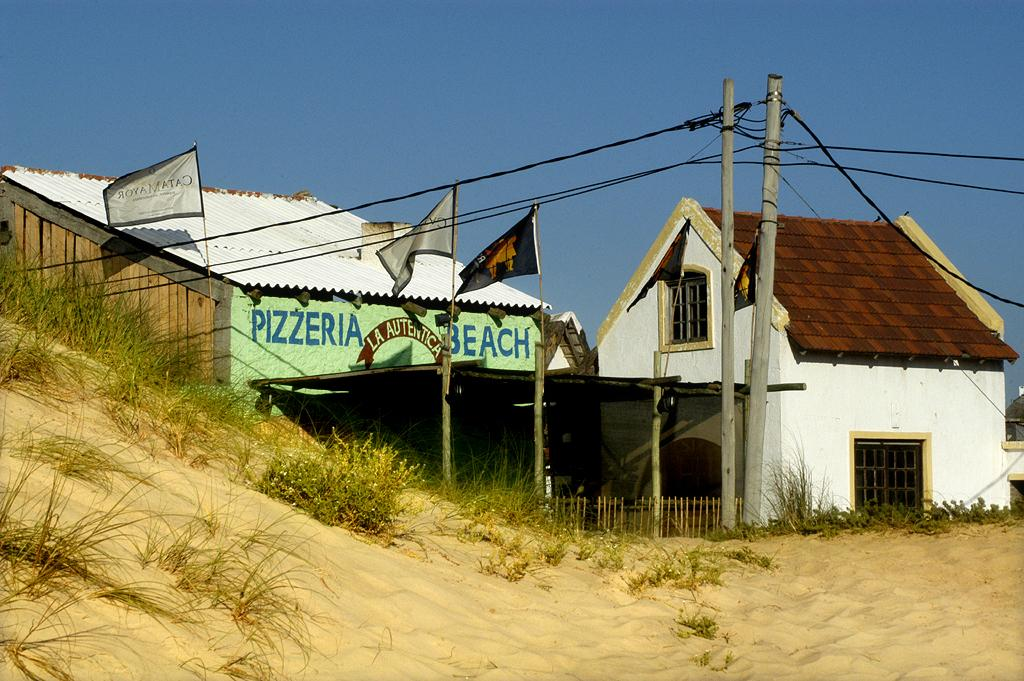How many houses can be seen in the image? There are two houses in the image. What else is present in the image besides the houses? There are flags and electrical poles with wires in the image. What is visible at the top of the image? The sky is visible at the top of the image. What type of terrain is depicted at the bottom of the image? There is sand with grass at the bottom of the image. Can you describe the battle that is taking place in the image? There is no battle present in the image; it features two houses, flags, electrical poles with wires, the sky, and sand with grass. 